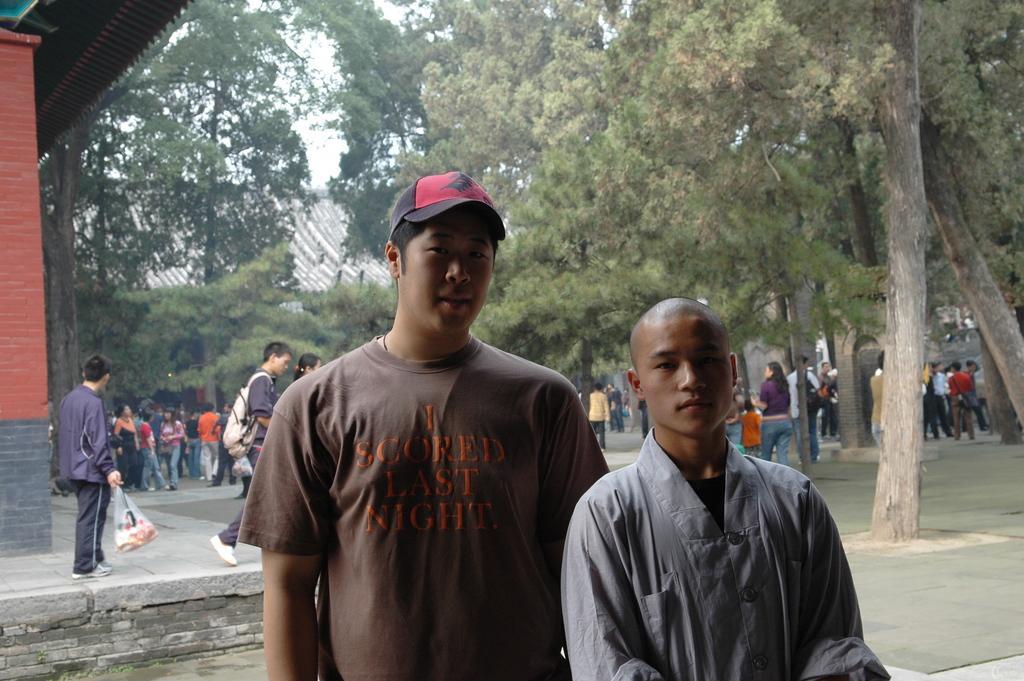In one or two sentences, can you explain what this image depicts? In the foreground we can see two men. In the middle of the picture there are trees, buildings, pavement and lot of people. At the top it is sky. 